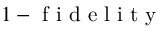Convert formula to latex. <formula><loc_0><loc_0><loc_500><loc_500>1 - f i d e l i t y</formula> 